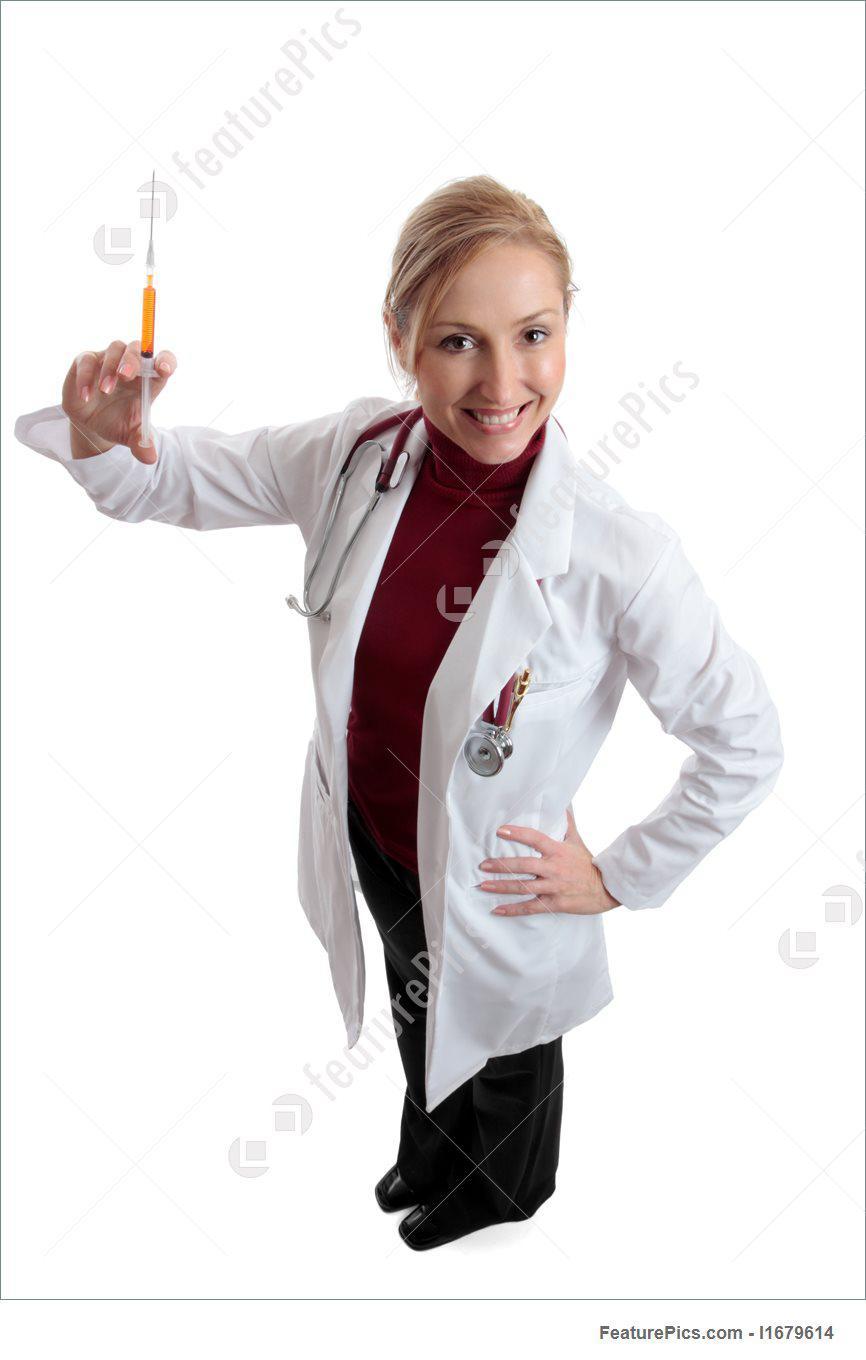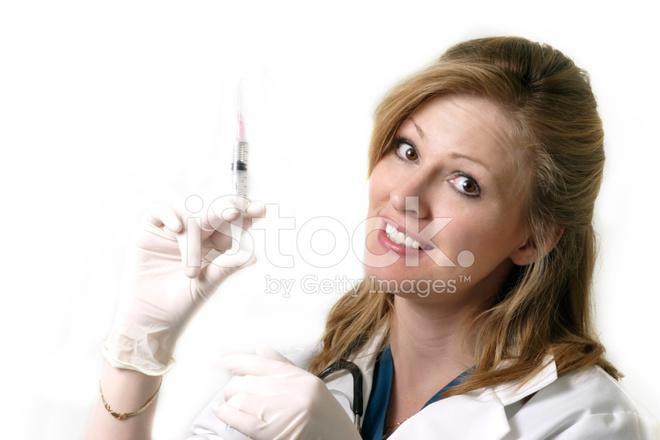The first image is the image on the left, the second image is the image on the right. Considering the images on both sides, is "The left and right image contains the same number of women holding needles." valid? Answer yes or no. Yes. The first image is the image on the left, the second image is the image on the right. For the images shown, is this caption "Both doctors are women holding needles." true? Answer yes or no. Yes. 